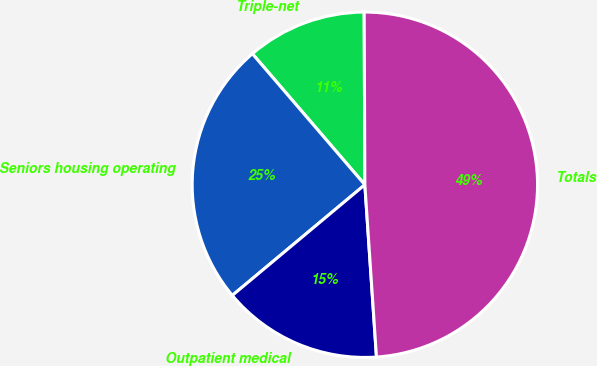Convert chart. <chart><loc_0><loc_0><loc_500><loc_500><pie_chart><fcel>Triple-net<fcel>Seniors housing operating<fcel>Outpatient medical<fcel>Totals<nl><fcel>11.23%<fcel>24.78%<fcel>15.0%<fcel>48.99%<nl></chart> 